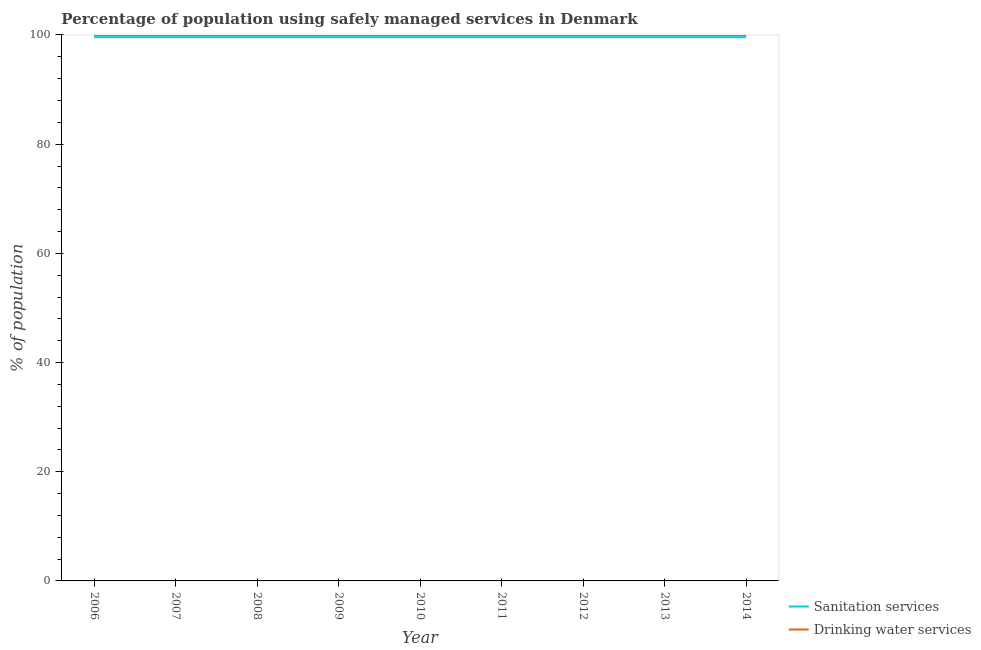How many different coloured lines are there?
Provide a short and direct response. 2. Is the number of lines equal to the number of legend labels?
Give a very brief answer. Yes. What is the percentage of population who used sanitation services in 2011?
Ensure brevity in your answer.  99.6. Across all years, what is the maximum percentage of population who used sanitation services?
Keep it short and to the point. 99.6. Across all years, what is the minimum percentage of population who used drinking water services?
Ensure brevity in your answer.  100. In which year was the percentage of population who used sanitation services maximum?
Your answer should be very brief. 2006. What is the total percentage of population who used sanitation services in the graph?
Make the answer very short. 896.4. What is the difference between the percentage of population who used drinking water services in 2009 and that in 2014?
Your response must be concise. 0. What is the difference between the percentage of population who used sanitation services in 2013 and the percentage of population who used drinking water services in 2008?
Offer a terse response. -0.4. What is the average percentage of population who used drinking water services per year?
Ensure brevity in your answer.  100. In the year 2006, what is the difference between the percentage of population who used sanitation services and percentage of population who used drinking water services?
Offer a very short reply. -0.4. In how many years, is the percentage of population who used drinking water services greater than 60 %?
Your response must be concise. 9. What is the ratio of the percentage of population who used drinking water services in 2006 to that in 2013?
Your answer should be very brief. 1. What is the difference between the highest and the second highest percentage of population who used drinking water services?
Your response must be concise. 0. Does the percentage of population who used drinking water services monotonically increase over the years?
Offer a terse response. No. Are the values on the major ticks of Y-axis written in scientific E-notation?
Your response must be concise. No. Does the graph contain any zero values?
Offer a terse response. No. Where does the legend appear in the graph?
Your response must be concise. Bottom right. How many legend labels are there?
Your answer should be compact. 2. What is the title of the graph?
Offer a very short reply. Percentage of population using safely managed services in Denmark. Does "Commercial bank branches" appear as one of the legend labels in the graph?
Your response must be concise. No. What is the label or title of the X-axis?
Keep it short and to the point. Year. What is the label or title of the Y-axis?
Provide a succinct answer. % of population. What is the % of population in Sanitation services in 2006?
Keep it short and to the point. 99.6. What is the % of population in Drinking water services in 2006?
Provide a succinct answer. 100. What is the % of population in Sanitation services in 2007?
Give a very brief answer. 99.6. What is the % of population in Sanitation services in 2008?
Ensure brevity in your answer.  99.6. What is the % of population of Drinking water services in 2008?
Give a very brief answer. 100. What is the % of population in Sanitation services in 2009?
Make the answer very short. 99.6. What is the % of population of Drinking water services in 2009?
Offer a terse response. 100. What is the % of population in Sanitation services in 2010?
Offer a very short reply. 99.6. What is the % of population in Sanitation services in 2011?
Keep it short and to the point. 99.6. What is the % of population of Sanitation services in 2012?
Keep it short and to the point. 99.6. What is the % of population of Sanitation services in 2013?
Offer a very short reply. 99.6. What is the % of population in Drinking water services in 2013?
Give a very brief answer. 100. What is the % of population in Sanitation services in 2014?
Provide a short and direct response. 99.6. What is the % of population in Drinking water services in 2014?
Provide a succinct answer. 100. Across all years, what is the maximum % of population of Sanitation services?
Your answer should be compact. 99.6. Across all years, what is the maximum % of population in Drinking water services?
Provide a succinct answer. 100. Across all years, what is the minimum % of population of Sanitation services?
Offer a terse response. 99.6. What is the total % of population in Sanitation services in the graph?
Offer a very short reply. 896.4. What is the total % of population of Drinking water services in the graph?
Ensure brevity in your answer.  900. What is the difference between the % of population of Sanitation services in 2006 and that in 2007?
Make the answer very short. 0. What is the difference between the % of population of Drinking water services in 2006 and that in 2007?
Ensure brevity in your answer.  0. What is the difference between the % of population of Drinking water services in 2006 and that in 2008?
Offer a terse response. 0. What is the difference between the % of population in Sanitation services in 2006 and that in 2009?
Provide a short and direct response. 0. What is the difference between the % of population of Drinking water services in 2006 and that in 2009?
Make the answer very short. 0. What is the difference between the % of population of Sanitation services in 2006 and that in 2010?
Offer a terse response. 0. What is the difference between the % of population in Drinking water services in 2006 and that in 2011?
Make the answer very short. 0. What is the difference between the % of population in Drinking water services in 2006 and that in 2013?
Your response must be concise. 0. What is the difference between the % of population in Sanitation services in 2007 and that in 2009?
Make the answer very short. 0. What is the difference between the % of population of Sanitation services in 2007 and that in 2011?
Offer a terse response. 0. What is the difference between the % of population of Drinking water services in 2007 and that in 2011?
Provide a short and direct response. 0. What is the difference between the % of population of Sanitation services in 2007 and that in 2013?
Ensure brevity in your answer.  0. What is the difference between the % of population in Sanitation services in 2007 and that in 2014?
Your answer should be very brief. 0. What is the difference between the % of population of Drinking water services in 2008 and that in 2010?
Provide a succinct answer. 0. What is the difference between the % of population of Drinking water services in 2008 and that in 2012?
Keep it short and to the point. 0. What is the difference between the % of population of Sanitation services in 2008 and that in 2013?
Your answer should be very brief. 0. What is the difference between the % of population of Drinking water services in 2008 and that in 2013?
Ensure brevity in your answer.  0. What is the difference between the % of population in Sanitation services in 2008 and that in 2014?
Your response must be concise. 0. What is the difference between the % of population in Sanitation services in 2009 and that in 2010?
Keep it short and to the point. 0. What is the difference between the % of population of Drinking water services in 2009 and that in 2011?
Provide a short and direct response. 0. What is the difference between the % of population of Sanitation services in 2009 and that in 2012?
Keep it short and to the point. 0. What is the difference between the % of population of Drinking water services in 2009 and that in 2012?
Your answer should be compact. 0. What is the difference between the % of population of Drinking water services in 2010 and that in 2011?
Your response must be concise. 0. What is the difference between the % of population of Sanitation services in 2010 and that in 2012?
Offer a terse response. 0. What is the difference between the % of population in Drinking water services in 2010 and that in 2012?
Keep it short and to the point. 0. What is the difference between the % of population in Drinking water services in 2010 and that in 2013?
Your answer should be very brief. 0. What is the difference between the % of population in Sanitation services in 2011 and that in 2012?
Provide a succinct answer. 0. What is the difference between the % of population in Drinking water services in 2011 and that in 2012?
Your answer should be very brief. 0. What is the difference between the % of population of Drinking water services in 2011 and that in 2013?
Your answer should be compact. 0. What is the difference between the % of population of Drinking water services in 2011 and that in 2014?
Keep it short and to the point. 0. What is the difference between the % of population in Drinking water services in 2012 and that in 2013?
Ensure brevity in your answer.  0. What is the difference between the % of population of Drinking water services in 2013 and that in 2014?
Your answer should be compact. 0. What is the difference between the % of population of Sanitation services in 2006 and the % of population of Drinking water services in 2007?
Provide a short and direct response. -0.4. What is the difference between the % of population in Sanitation services in 2006 and the % of population in Drinking water services in 2008?
Offer a very short reply. -0.4. What is the difference between the % of population of Sanitation services in 2006 and the % of population of Drinking water services in 2009?
Give a very brief answer. -0.4. What is the difference between the % of population in Sanitation services in 2006 and the % of population in Drinking water services in 2013?
Offer a terse response. -0.4. What is the difference between the % of population in Sanitation services in 2006 and the % of population in Drinking water services in 2014?
Offer a very short reply. -0.4. What is the difference between the % of population of Sanitation services in 2007 and the % of population of Drinking water services in 2010?
Keep it short and to the point. -0.4. What is the difference between the % of population of Sanitation services in 2007 and the % of population of Drinking water services in 2013?
Your answer should be very brief. -0.4. What is the difference between the % of population of Sanitation services in 2008 and the % of population of Drinking water services in 2009?
Provide a succinct answer. -0.4. What is the difference between the % of population of Sanitation services in 2009 and the % of population of Drinking water services in 2010?
Offer a very short reply. -0.4. What is the difference between the % of population of Sanitation services in 2009 and the % of population of Drinking water services in 2011?
Provide a succinct answer. -0.4. What is the difference between the % of population of Sanitation services in 2009 and the % of population of Drinking water services in 2012?
Keep it short and to the point. -0.4. What is the difference between the % of population of Sanitation services in 2009 and the % of population of Drinking water services in 2013?
Your response must be concise. -0.4. What is the difference between the % of population of Sanitation services in 2009 and the % of population of Drinking water services in 2014?
Make the answer very short. -0.4. What is the difference between the % of population of Sanitation services in 2010 and the % of population of Drinking water services in 2011?
Provide a short and direct response. -0.4. What is the difference between the % of population in Sanitation services in 2010 and the % of population in Drinking water services in 2013?
Keep it short and to the point. -0.4. What is the difference between the % of population of Sanitation services in 2011 and the % of population of Drinking water services in 2012?
Provide a succinct answer. -0.4. What is the difference between the % of population in Sanitation services in 2012 and the % of population in Drinking water services in 2014?
Your answer should be very brief. -0.4. What is the average % of population in Sanitation services per year?
Your answer should be very brief. 99.6. What is the average % of population of Drinking water services per year?
Your response must be concise. 100. In the year 2008, what is the difference between the % of population of Sanitation services and % of population of Drinking water services?
Provide a succinct answer. -0.4. In the year 2011, what is the difference between the % of population in Sanitation services and % of population in Drinking water services?
Give a very brief answer. -0.4. In the year 2012, what is the difference between the % of population of Sanitation services and % of population of Drinking water services?
Make the answer very short. -0.4. In the year 2013, what is the difference between the % of population of Sanitation services and % of population of Drinking water services?
Offer a very short reply. -0.4. What is the ratio of the % of population of Sanitation services in 2006 to that in 2008?
Offer a very short reply. 1. What is the ratio of the % of population in Sanitation services in 2006 to that in 2009?
Your response must be concise. 1. What is the ratio of the % of population in Sanitation services in 2006 to that in 2010?
Provide a succinct answer. 1. What is the ratio of the % of population of Drinking water services in 2006 to that in 2010?
Offer a very short reply. 1. What is the ratio of the % of population in Sanitation services in 2006 to that in 2011?
Provide a short and direct response. 1. What is the ratio of the % of population in Drinking water services in 2006 to that in 2011?
Provide a succinct answer. 1. What is the ratio of the % of population of Drinking water services in 2006 to that in 2012?
Make the answer very short. 1. What is the ratio of the % of population in Drinking water services in 2006 to that in 2013?
Ensure brevity in your answer.  1. What is the ratio of the % of population in Sanitation services in 2007 to that in 2008?
Give a very brief answer. 1. What is the ratio of the % of population of Drinking water services in 2007 to that in 2008?
Your response must be concise. 1. What is the ratio of the % of population of Sanitation services in 2007 to that in 2009?
Provide a succinct answer. 1. What is the ratio of the % of population in Sanitation services in 2007 to that in 2010?
Your response must be concise. 1. What is the ratio of the % of population in Drinking water services in 2007 to that in 2010?
Your answer should be compact. 1. What is the ratio of the % of population in Drinking water services in 2007 to that in 2012?
Ensure brevity in your answer.  1. What is the ratio of the % of population of Sanitation services in 2007 to that in 2013?
Your answer should be very brief. 1. What is the ratio of the % of population in Drinking water services in 2007 to that in 2013?
Provide a succinct answer. 1. What is the ratio of the % of population in Sanitation services in 2008 to that in 2009?
Keep it short and to the point. 1. What is the ratio of the % of population of Drinking water services in 2008 to that in 2009?
Your answer should be compact. 1. What is the ratio of the % of population in Drinking water services in 2008 to that in 2010?
Ensure brevity in your answer.  1. What is the ratio of the % of population of Sanitation services in 2008 to that in 2012?
Offer a terse response. 1. What is the ratio of the % of population in Drinking water services in 2008 to that in 2012?
Your answer should be very brief. 1. What is the ratio of the % of population of Sanitation services in 2008 to that in 2013?
Provide a succinct answer. 1. What is the ratio of the % of population in Sanitation services in 2008 to that in 2014?
Keep it short and to the point. 1. What is the ratio of the % of population of Drinking water services in 2008 to that in 2014?
Offer a terse response. 1. What is the ratio of the % of population in Drinking water services in 2009 to that in 2012?
Provide a succinct answer. 1. What is the ratio of the % of population of Drinking water services in 2009 to that in 2013?
Ensure brevity in your answer.  1. What is the ratio of the % of population in Sanitation services in 2009 to that in 2014?
Provide a short and direct response. 1. What is the ratio of the % of population in Drinking water services in 2009 to that in 2014?
Keep it short and to the point. 1. What is the ratio of the % of population in Drinking water services in 2010 to that in 2011?
Give a very brief answer. 1. What is the ratio of the % of population in Drinking water services in 2010 to that in 2012?
Offer a terse response. 1. What is the ratio of the % of population in Drinking water services in 2010 to that in 2013?
Provide a short and direct response. 1. What is the ratio of the % of population in Drinking water services in 2010 to that in 2014?
Keep it short and to the point. 1. What is the ratio of the % of population of Drinking water services in 2011 to that in 2013?
Ensure brevity in your answer.  1. What is the ratio of the % of population of Sanitation services in 2011 to that in 2014?
Keep it short and to the point. 1. What is the ratio of the % of population of Sanitation services in 2012 to that in 2013?
Your answer should be very brief. 1. What is the ratio of the % of population in Drinking water services in 2012 to that in 2013?
Offer a very short reply. 1. What is the ratio of the % of population of Sanitation services in 2012 to that in 2014?
Your answer should be very brief. 1. What is the ratio of the % of population of Drinking water services in 2012 to that in 2014?
Your answer should be very brief. 1. What is the ratio of the % of population in Drinking water services in 2013 to that in 2014?
Your answer should be compact. 1. What is the difference between the highest and the second highest % of population of Sanitation services?
Your response must be concise. 0. 